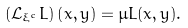<formula> <loc_0><loc_0><loc_500><loc_500>( \mathcal { L } _ { \xi ^ { c } } L ) \left ( x , y \right ) = \mu L ( x , y ) .</formula> 